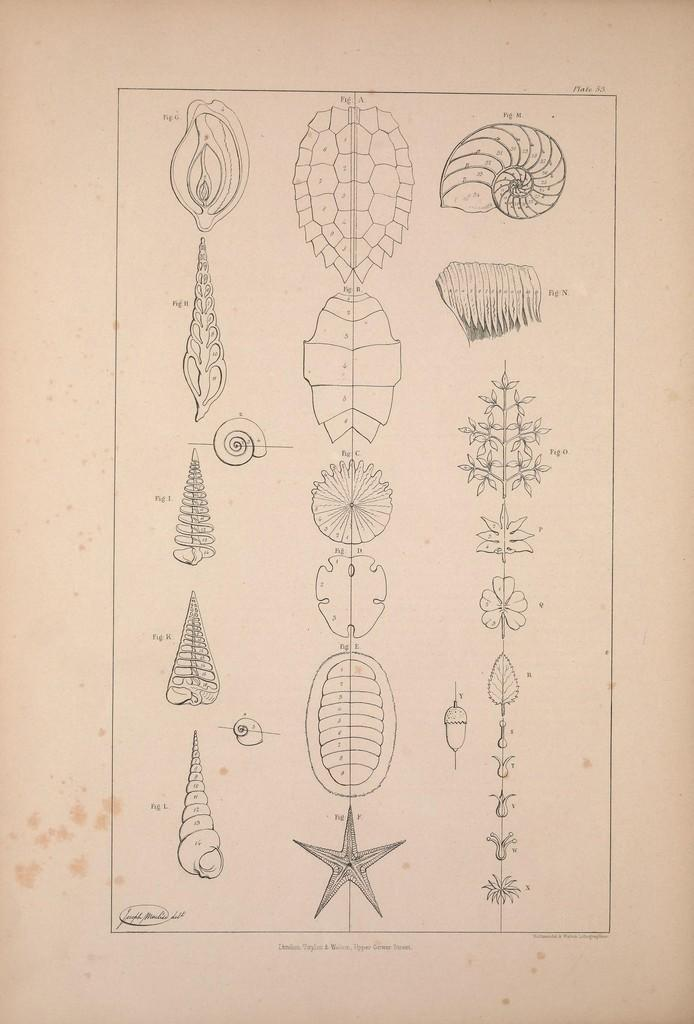What is the primary feature of the image? The primary feature of the image is the figures labeled with numbers. What is the background of the image? The figures are on a white surface. Is there any text present in the image? Yes, there is text at the bottom of the image. Is there an umbrella being used by any of the figures in the image? There is no umbrella present in the image. What type of home is depicted in the image? The image does not depict a home; it features figures labeled with numbers on a white surface with text at the bottom. 